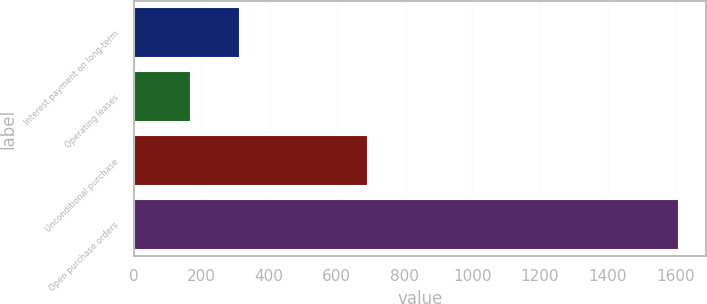Convert chart to OTSL. <chart><loc_0><loc_0><loc_500><loc_500><bar_chart><fcel>Interest payment on long-term<fcel>Operating leases<fcel>Unconditional purchase<fcel>Open purchase orders<nl><fcel>313.1<fcel>169<fcel>693<fcel>1610<nl></chart> 